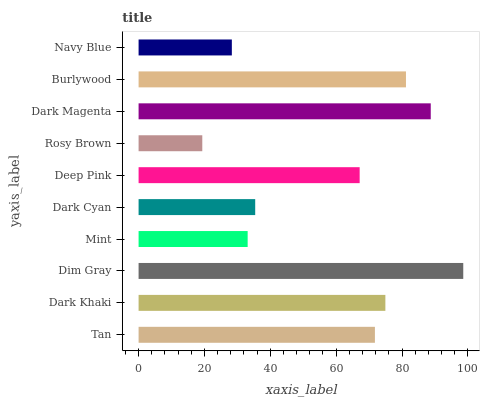Is Rosy Brown the minimum?
Answer yes or no. Yes. Is Dim Gray the maximum?
Answer yes or no. Yes. Is Dark Khaki the minimum?
Answer yes or no. No. Is Dark Khaki the maximum?
Answer yes or no. No. Is Dark Khaki greater than Tan?
Answer yes or no. Yes. Is Tan less than Dark Khaki?
Answer yes or no. Yes. Is Tan greater than Dark Khaki?
Answer yes or no. No. Is Dark Khaki less than Tan?
Answer yes or no. No. Is Tan the high median?
Answer yes or no. Yes. Is Deep Pink the low median?
Answer yes or no. Yes. Is Dark Cyan the high median?
Answer yes or no. No. Is Rosy Brown the low median?
Answer yes or no. No. 